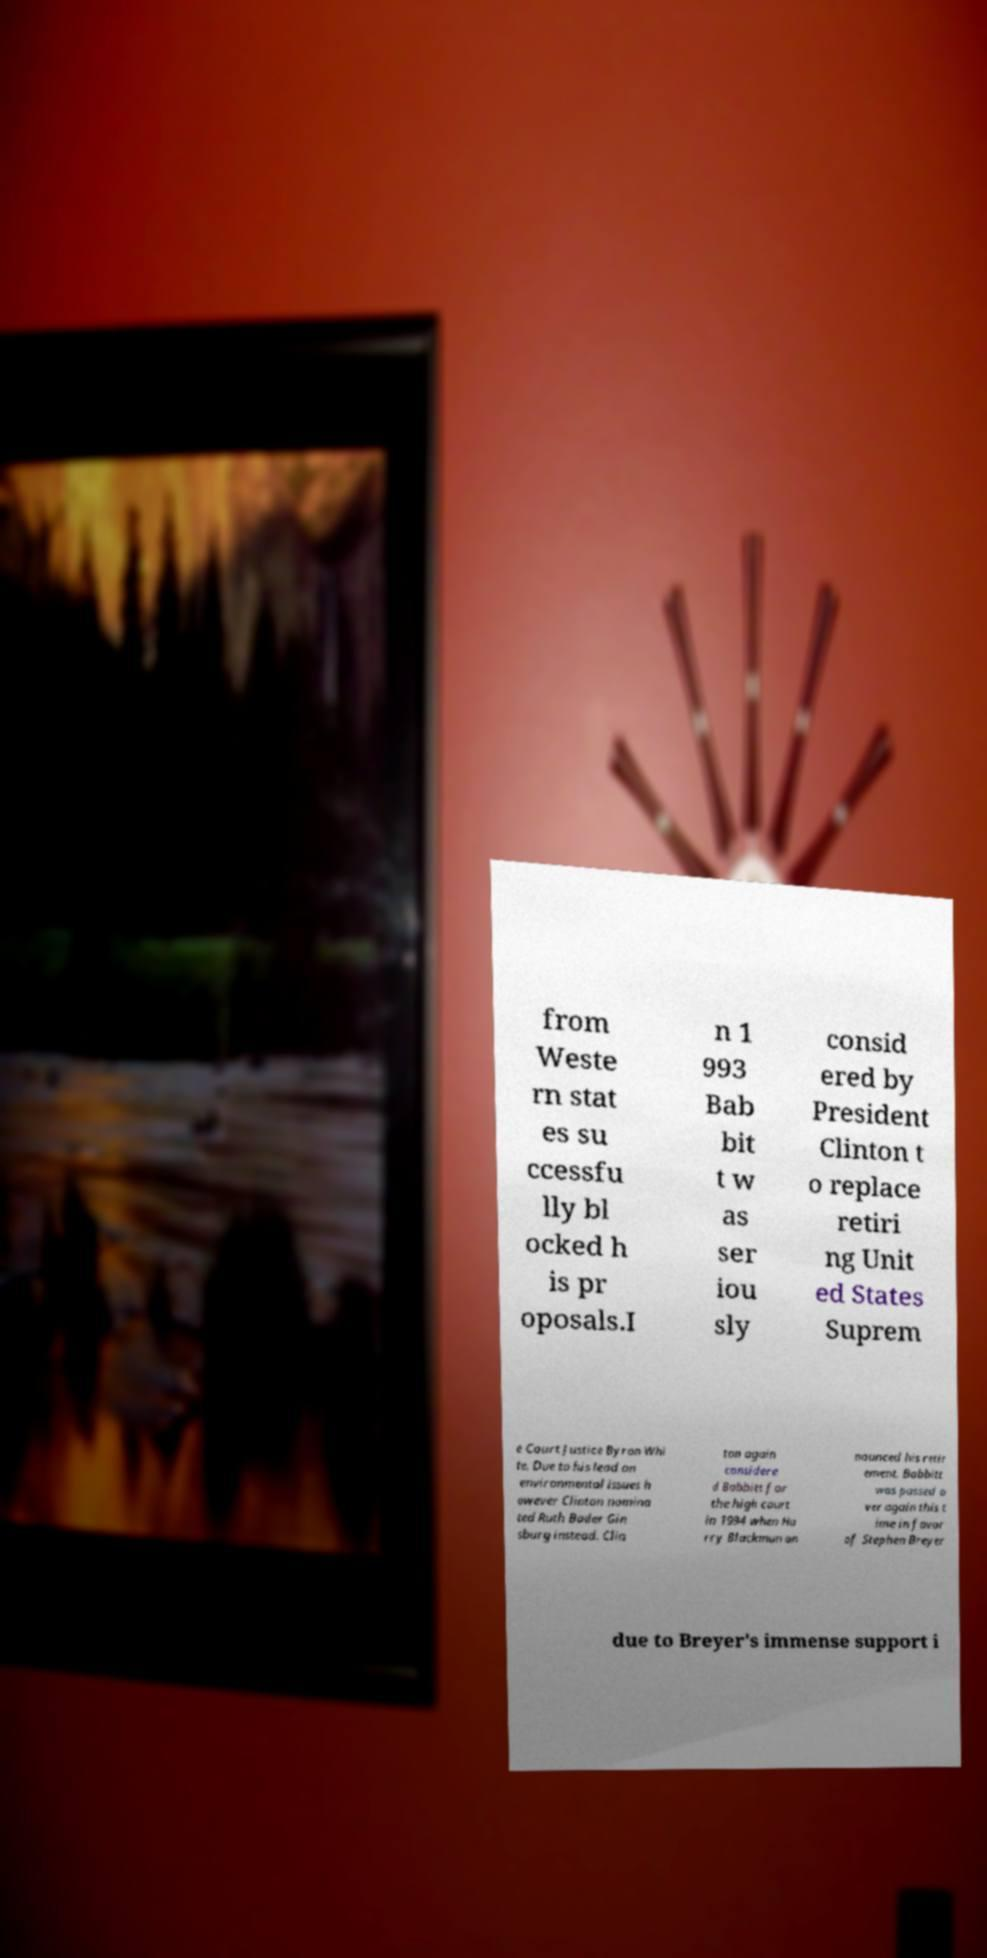Can you read and provide the text displayed in the image?This photo seems to have some interesting text. Can you extract and type it out for me? from Weste rn stat es su ccessfu lly bl ocked h is pr oposals.I n 1 993 Bab bit t w as ser iou sly consid ered by President Clinton t o replace retiri ng Unit ed States Suprem e Court Justice Byron Whi te. Due to his lead on environmental issues h owever Clinton nomina ted Ruth Bader Gin sburg instead. Clin ton again considere d Babbitt for the high court in 1994 when Ha rry Blackmun an nounced his retir ement. Babbitt was passed o ver again this t ime in favor of Stephen Breyer due to Breyer's immense support i 